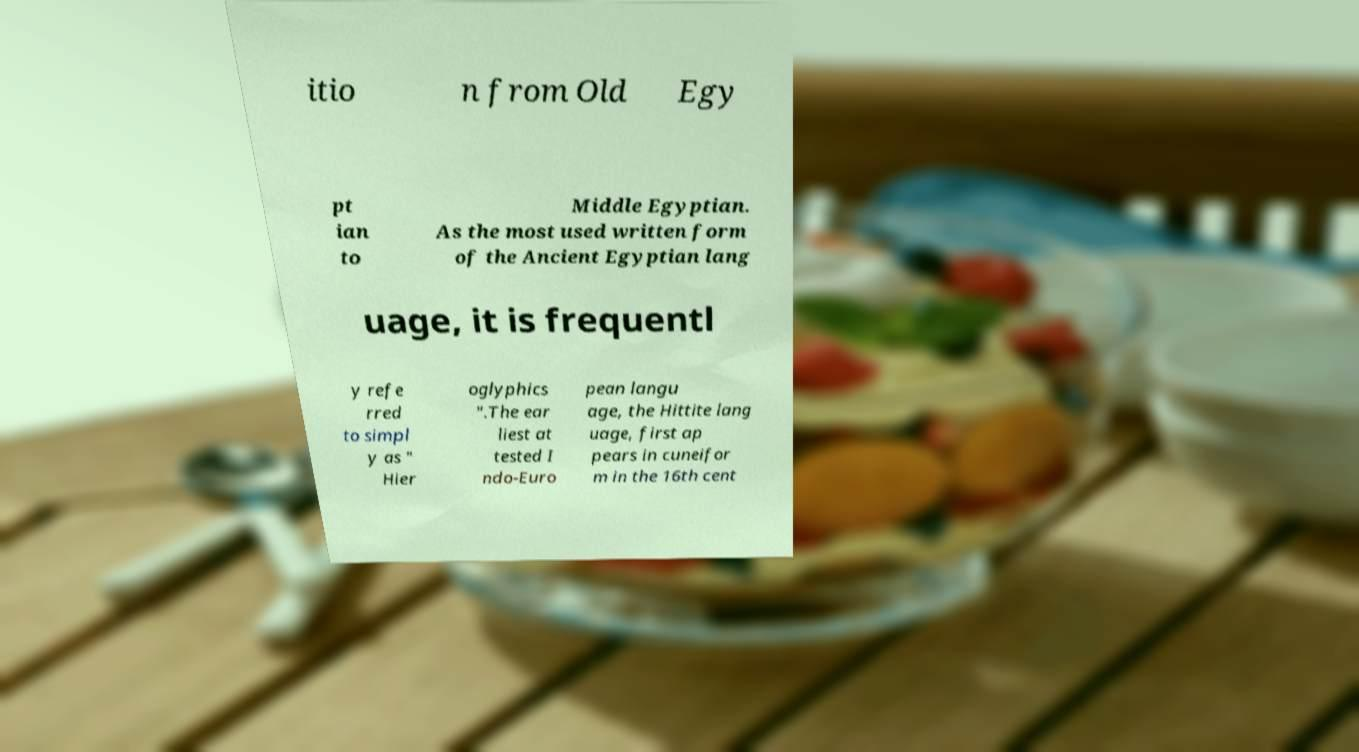Could you assist in decoding the text presented in this image and type it out clearly? itio n from Old Egy pt ian to Middle Egyptian. As the most used written form of the Ancient Egyptian lang uage, it is frequentl y refe rred to simpl y as " Hier oglyphics ".The ear liest at tested I ndo-Euro pean langu age, the Hittite lang uage, first ap pears in cuneifor m in the 16th cent 